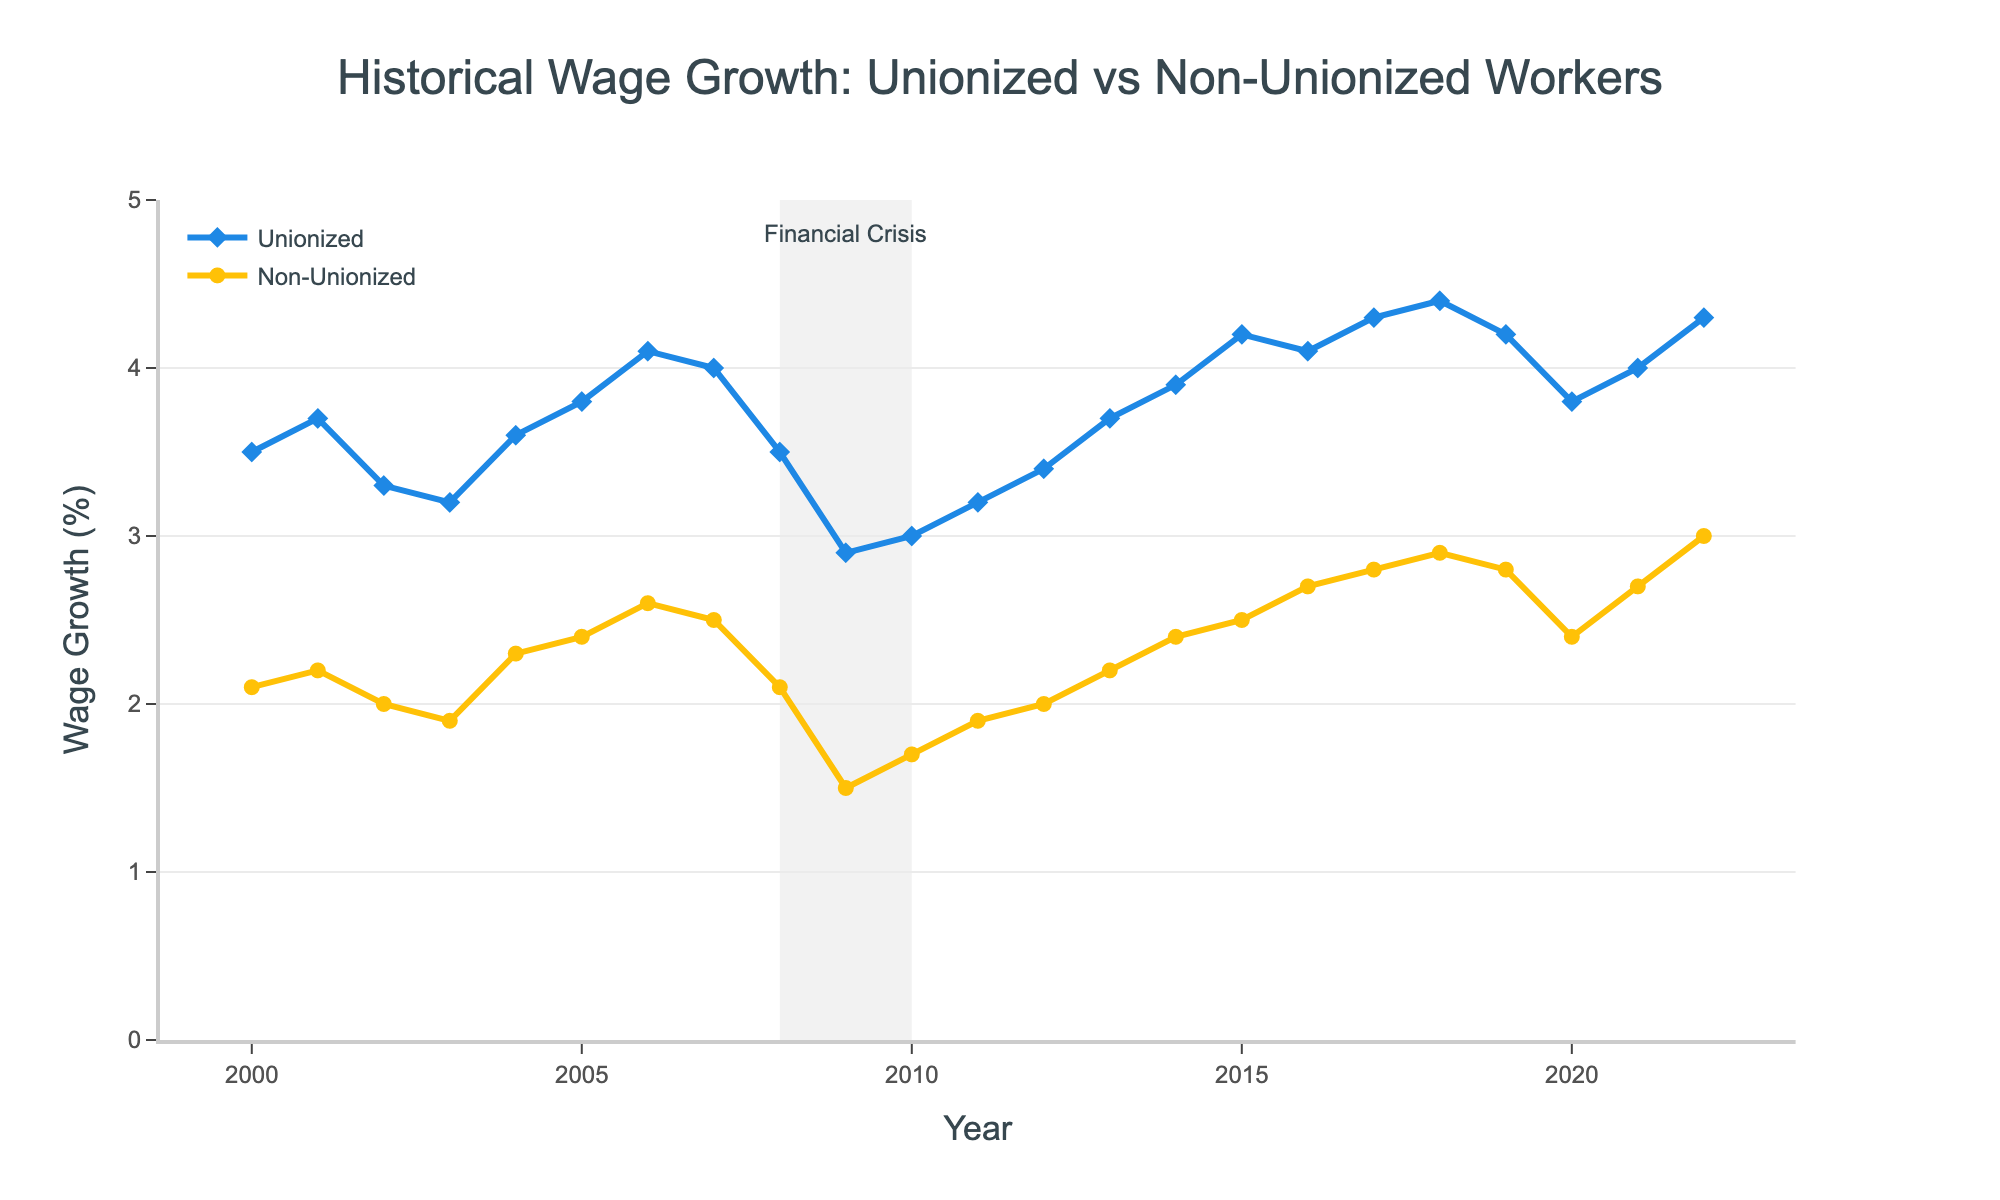What is the title of the figure? The title is usually placed at the top center of a figure. In this case, it reads "Historical Wage Growth: Unionized vs Non-Unionized Workers"
Answer: Historical Wage Growth: Unionized vs Non-Unionized Workers How is the wage growth trend of unionized workers from 2009 to 2011? Observe the line representing unionized workers from 2009 to 2011. The data points for unionized wage growth in these years are 2.9, 3.0, and 3.2, indicating a slight increase.
Answer: Slight increase Which group had a higher wage growth in 2022? Compare the wage growth values for unionized and non-unionized workers in 2022. Unionized workers have a wage growth of 4.3%, while non-unionized workers have 3.0%.
Answer: Unionized workers What is the difference in wage growth between unionized and non-unionized workers in 2016? Locate the wage growth values for 2016: Unionized (4.1%) and Non-Unionized (2.7%). Subtract the latter from the former: 4.1% - 2.7% = 1.4%.
Answer: 1.4% What happens to wage growth trends during the financial crisis period marked in the figure? The shaded area represents the financial crisis from 2008 to 2010. Both wage growth trends seem to dip during this period. For unionized workers, it declines from 3.5 to 2.9 and then rises to 3.0. For non-unionized workers, it decreases from 2.1 to 1.5 and then to 1.7.
Answer: Both decline Between which years did unionized workers see the highest wage growth increase? Examine the wage growth values for unionized workers year-by-year. The highest increase appears between 2014 (3.9%) and 2015 (4.2%), representing a 0.3% increase.
Answer: 2014-2015 What is the average wage growth of non-unionized workers from 2010 to 2020? Sum the wage growth values for non-unionized workers from 2010 (1.7%) to 2020 (2.4%) and then divide by the number of years. The sum is 25.0 and there are 11 years. Therefore, the average is 25.0 / 11 = ~2.27%.
Answer: ~2.27% Identify a period where the wage growth of non-unionized workers remained constant. Look for flat segments in the line representing non-unionized workers. From 2007 to 2008, both values are 2.5%.
Answer: 2007-2008 